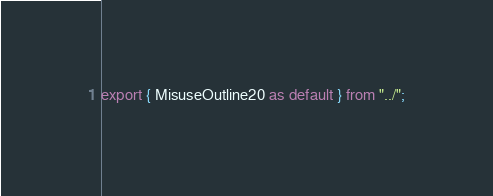<code> <loc_0><loc_0><loc_500><loc_500><_TypeScript_>export { MisuseOutline20 as default } from "../";
</code> 